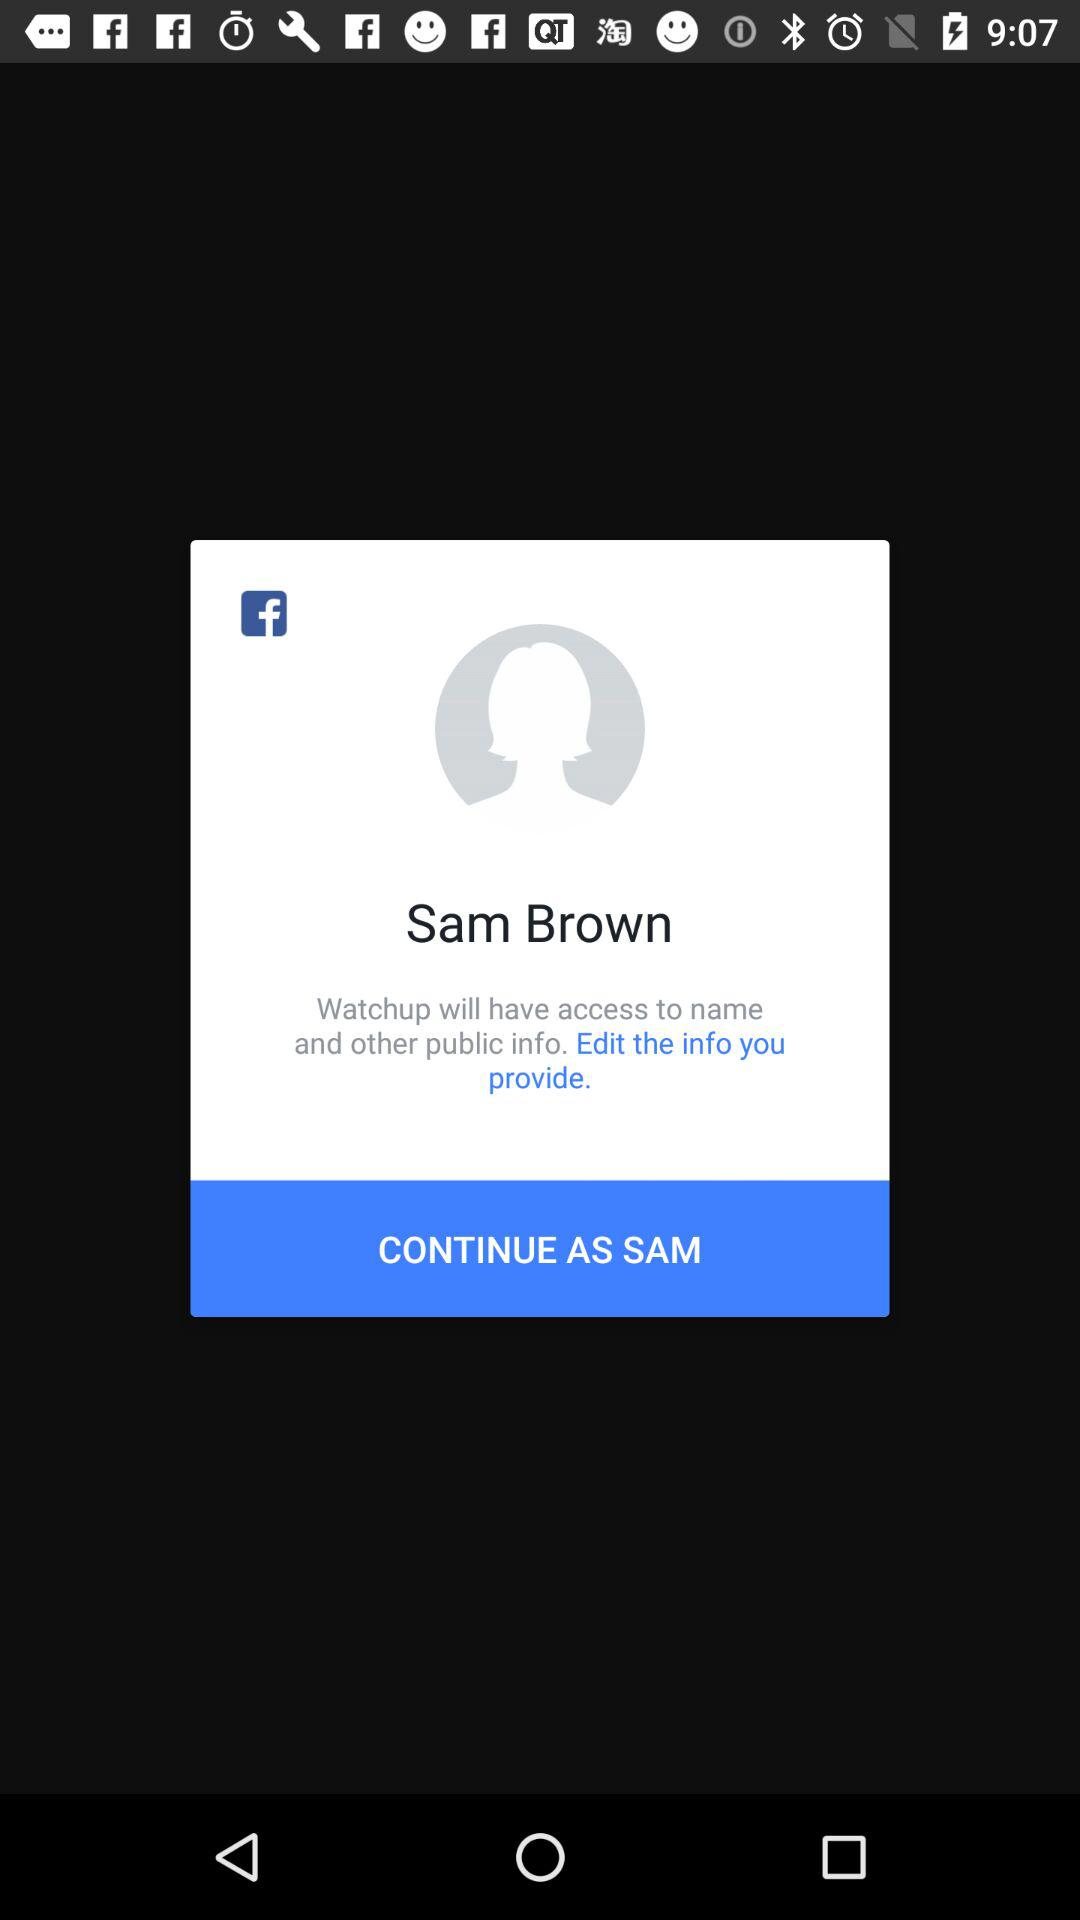Through what applications can the user continue? The user can continue through "Facebook". 